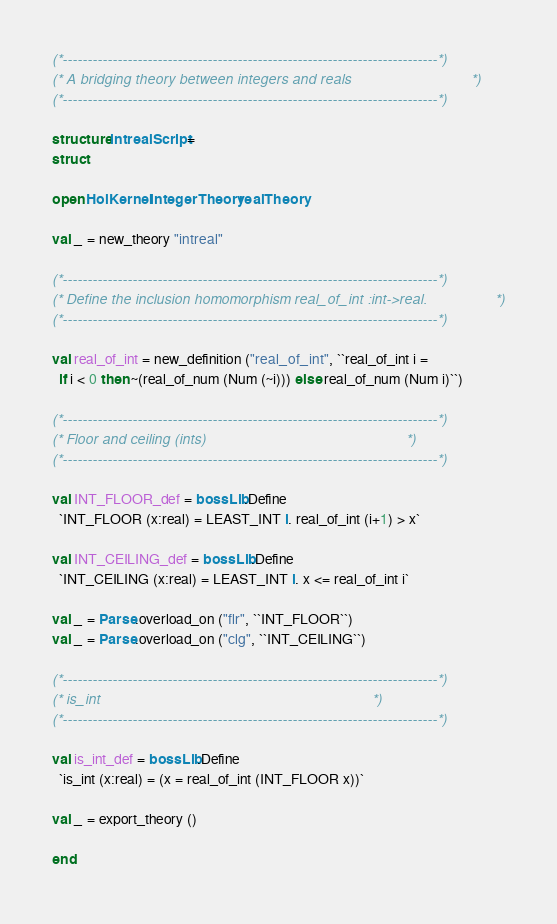Convert code to text. <code><loc_0><loc_0><loc_500><loc_500><_SML_>(*---------------------------------------------------------------------------*)
(* A bridging theory between integers and reals                              *)
(*---------------------------------------------------------------------------*)

structure intrealScript =
struct

open HolKernel integerTheory realTheory

val _ = new_theory "intreal"

(*---------------------------------------------------------------------------*)
(* Define the inclusion homomorphism real_of_int :int->real.                 *)
(*---------------------------------------------------------------------------*)

val real_of_int = new_definition ("real_of_int", ``real_of_int i =
  if i < 0 then ~(real_of_num (Num (~i))) else real_of_num (Num i)``)

(*---------------------------------------------------------------------------*)
(* Floor and ceiling (ints)                                                  *)
(*---------------------------------------------------------------------------*)

val INT_FLOOR_def = bossLib.Define
  `INT_FLOOR (x:real) = LEAST_INT i. real_of_int (i+1) > x`

val INT_CEILING_def = bossLib.Define
  `INT_CEILING (x:real) = LEAST_INT i. x <= real_of_int i`

val _ = Parse.overload_on ("flr", ``INT_FLOOR``)
val _ = Parse.overload_on ("clg", ``INT_CEILING``)

(*---------------------------------------------------------------------------*)
(* is_int                                                                    *)
(*---------------------------------------------------------------------------*)

val is_int_def = bossLib.Define
  `is_int (x:real) = (x = real_of_int (INT_FLOOR x))`

val _ = export_theory ()

end
</code> 